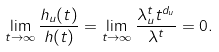Convert formula to latex. <formula><loc_0><loc_0><loc_500><loc_500>\lim _ { t \to \infty } \frac { h _ { u } ( t ) } { h ( t ) } = \lim _ { t \to \infty } \frac { \lambda _ { u } ^ { t } t ^ { d _ { u } } } { \lambda ^ { t } } = 0 .</formula> 